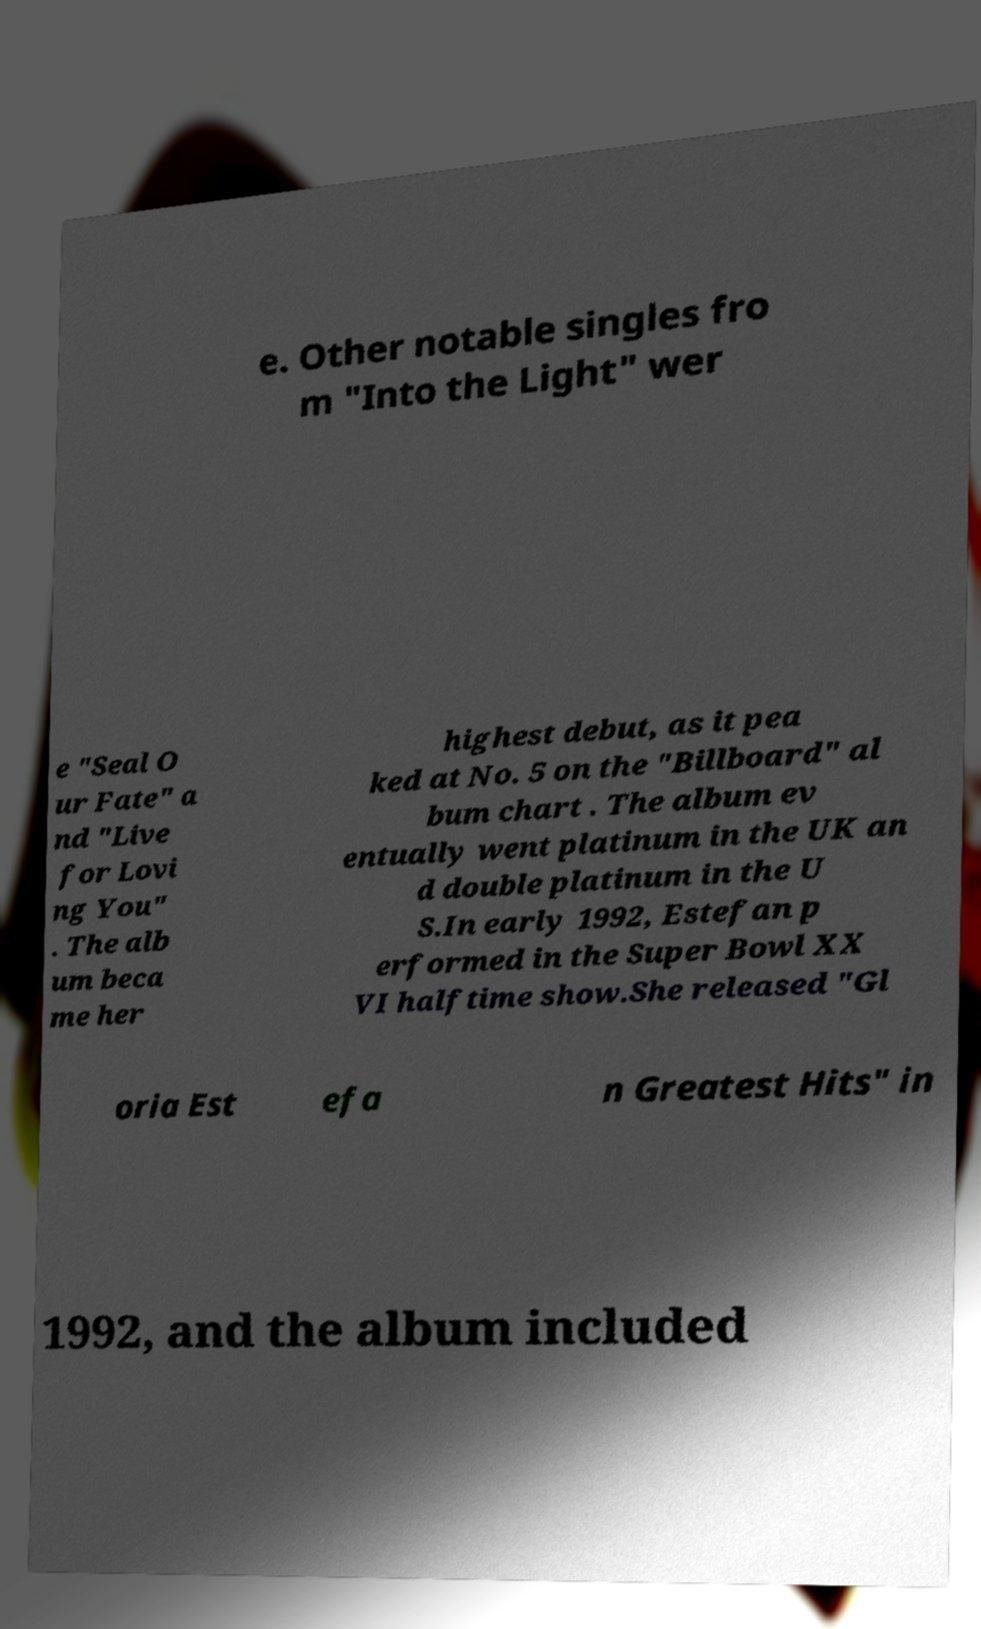Can you read and provide the text displayed in the image?This photo seems to have some interesting text. Can you extract and type it out for me? e. Other notable singles fro m "Into the Light" wer e "Seal O ur Fate" a nd "Live for Lovi ng You" . The alb um beca me her highest debut, as it pea ked at No. 5 on the "Billboard" al bum chart . The album ev entually went platinum in the UK an d double platinum in the U S.In early 1992, Estefan p erformed in the Super Bowl XX VI halftime show.She released "Gl oria Est efa n Greatest Hits" in 1992, and the album included 